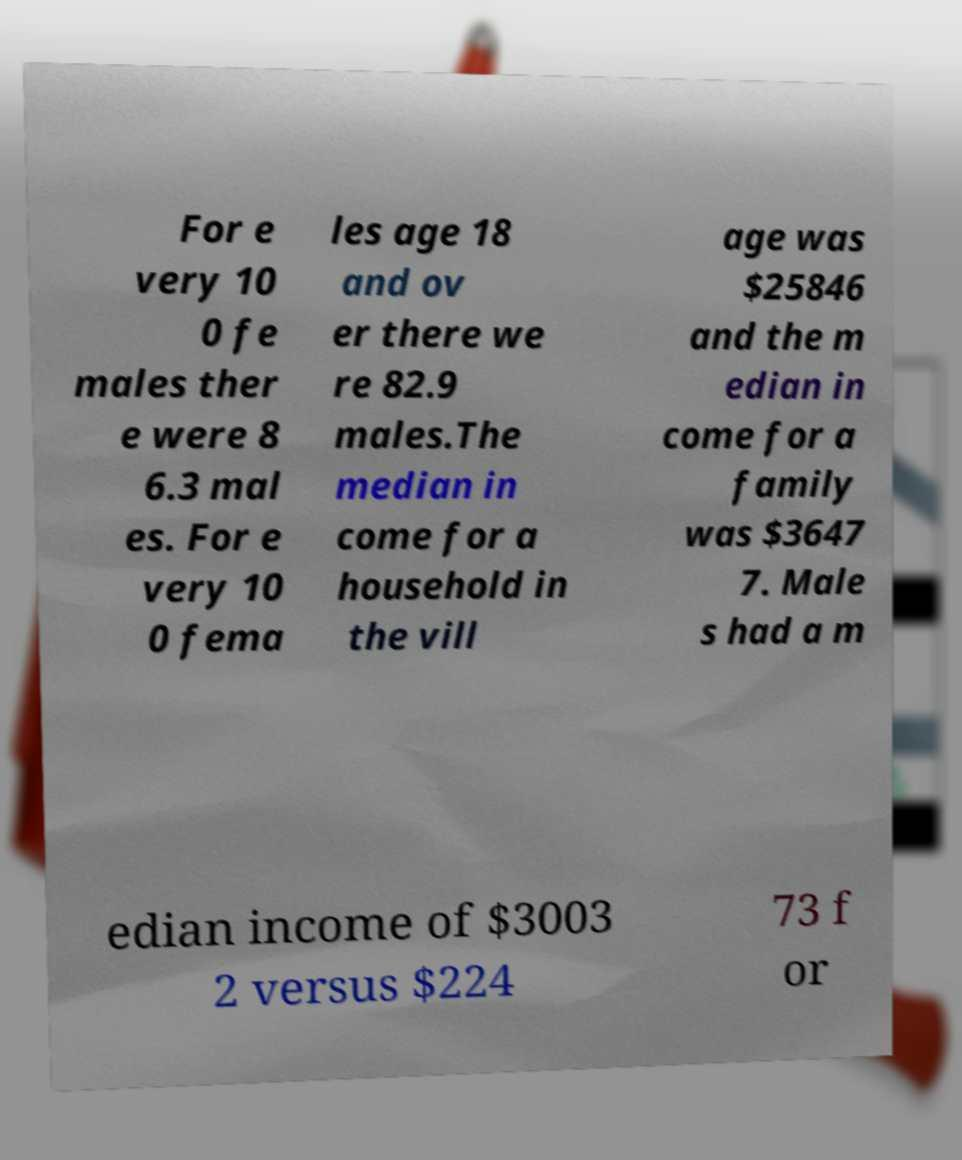Please read and relay the text visible in this image. What does it say? For e very 10 0 fe males ther e were 8 6.3 mal es. For e very 10 0 fema les age 18 and ov er there we re 82.9 males.The median in come for a household in the vill age was $25846 and the m edian in come for a family was $3647 7. Male s had a m edian income of $3003 2 versus $224 73 f or 